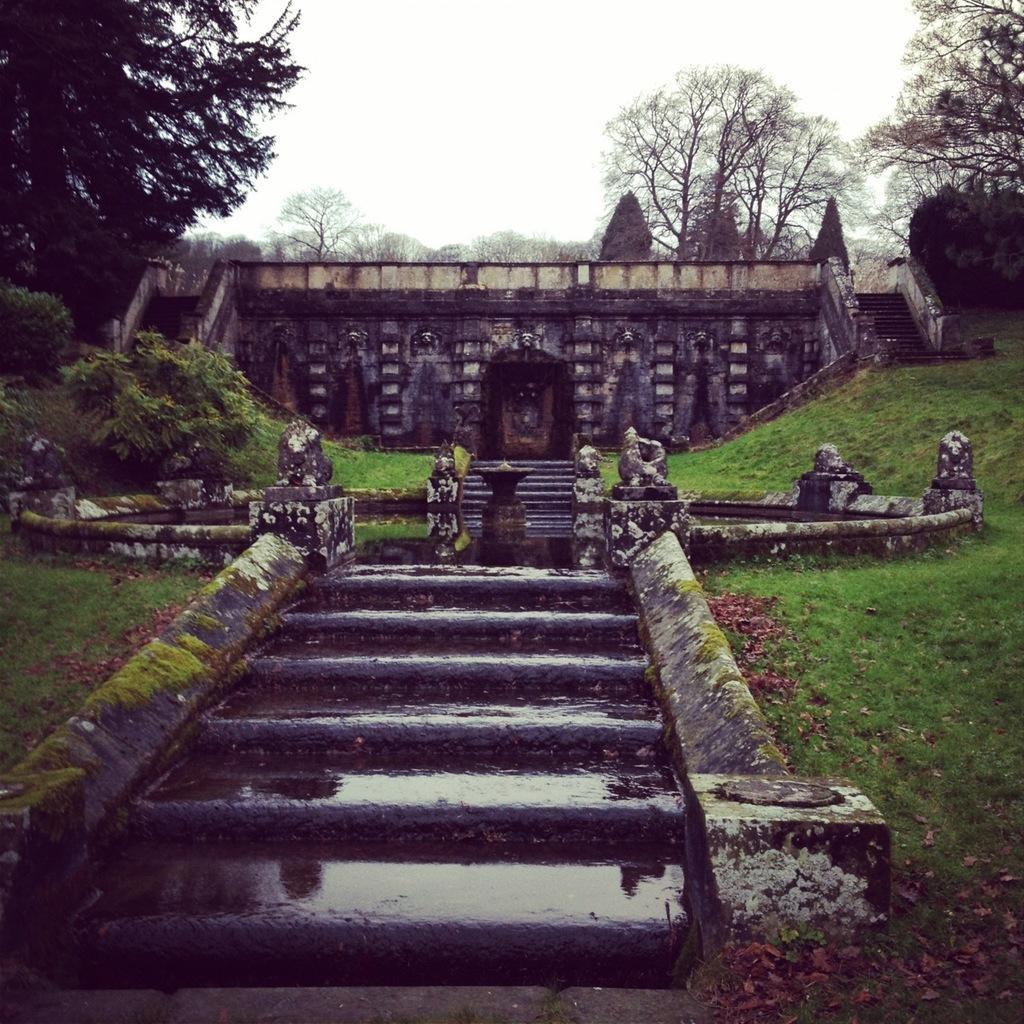In one or two sentences, can you explain what this image depicts? In this image there is grass. There are steps. There is a building. There are trees in the background. There is a sky. 